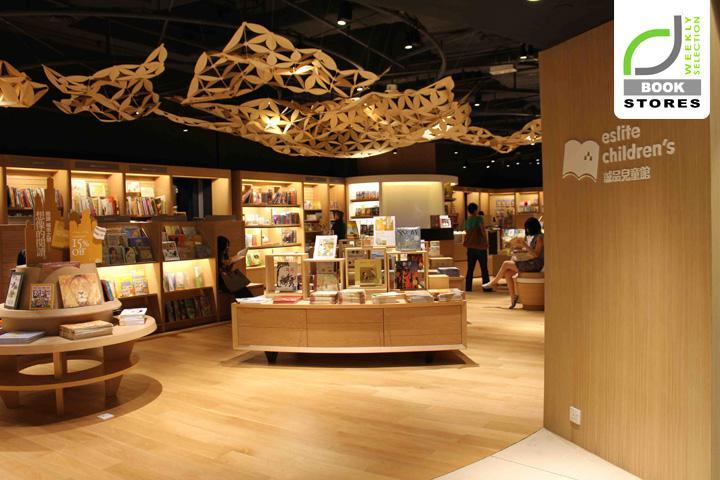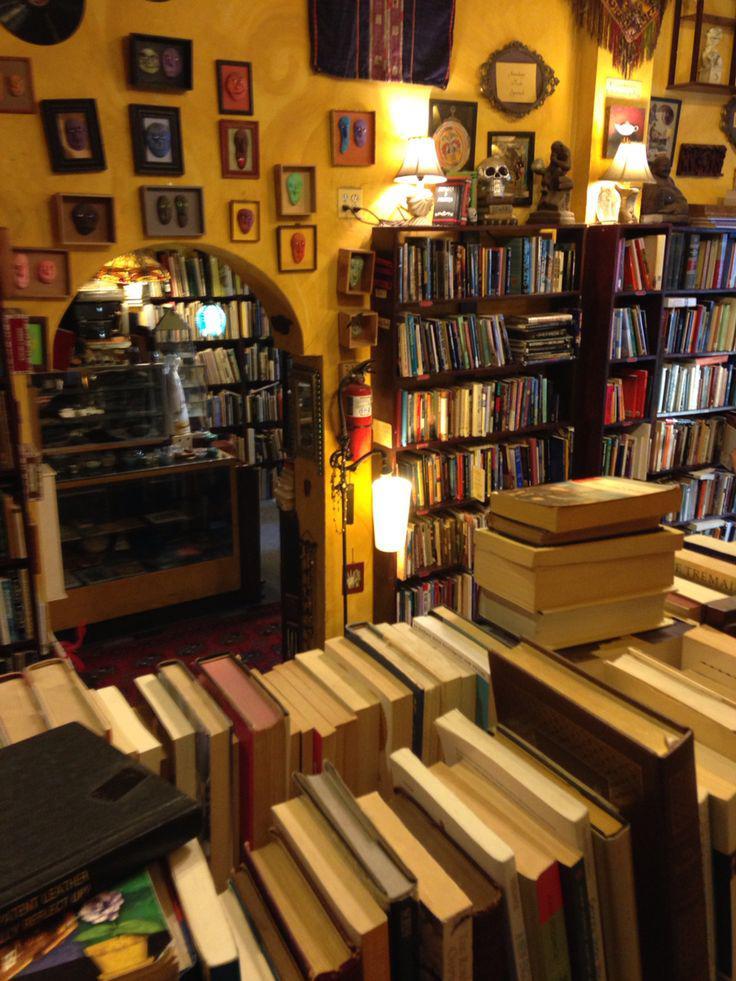The first image is the image on the left, the second image is the image on the right. Analyze the images presented: Is the assertion "The left image features books arranged on tiered shelves of a wooden pyramid-shaped structure in a library with a wood floor." valid? Answer yes or no. Yes. 